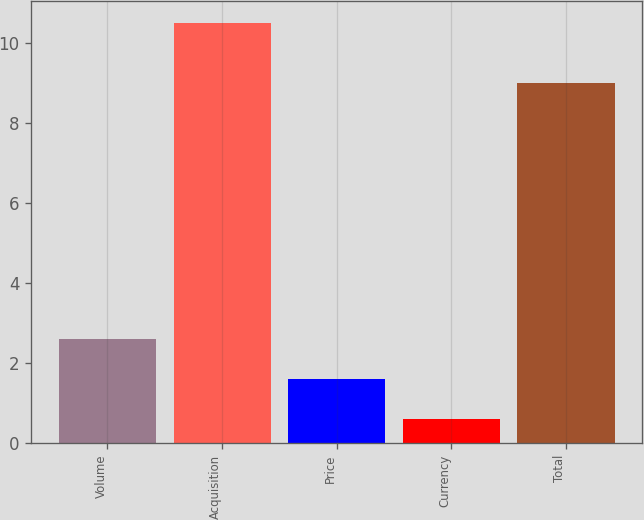Convert chart to OTSL. <chart><loc_0><loc_0><loc_500><loc_500><bar_chart><fcel>Volume<fcel>Acquisition<fcel>Price<fcel>Currency<fcel>Total<nl><fcel>2.58<fcel>10.5<fcel>1.59<fcel>0.6<fcel>9<nl></chart> 